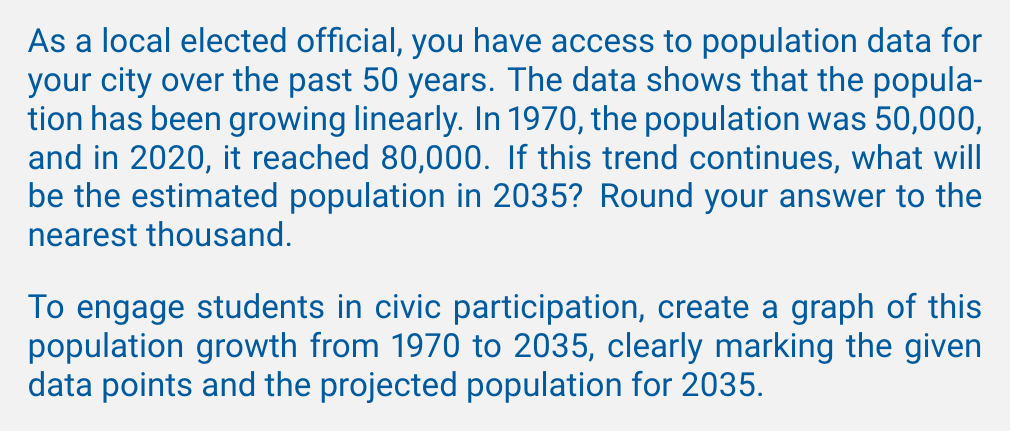Help me with this question. To solve this problem, we need to follow these steps:

1. Calculate the rate of population growth per year:
   Let $y$ represent the population and $x$ represent the years since 1970.
   We can use the point-slope form of a linear equation: $y - y_1 = m(x - x_1)$

   $m = \frac{y_2 - y_1}{x_2 - x_1} = \frac{80,000 - 50,000}{2020 - 1970} = \frac{30,000}{50} = 600$ people per year

2. Write the linear equation for population growth:
   $y - 50,000 = 600(x - 0)$
   $y = 600x + 50,000$

3. Calculate the population in 2035:
   $x = 2035 - 1970 = 65$ years since 1970
   $y = 600(65) + 50,000 = 89,000$

4. To create the graph:
   - X-axis: Years from 1970 to 2035
   - Y-axis: Population from 50,000 to 90,000
   - Plot points: (1970, 50,000), (2020, 80,000), and (2035, 89,000)
   - Draw a straight line through these points

[asy]
import graph;
size(300,200);

real f(real x) {return 600*x + 50000;}

xaxis("Year",Ticks(Label(),2,1970,2035));
yaxis("Population",Ticks(Label(),10000,50000,90000));

draw(graph(f,0,65,operator ..),blue);

dot((0,50000),red);
dot((50,80000),red);
dot((65,89000),red);

label("1970",(0,50000),SW);
label("2020",(50,80000),NW);
label("2035",(65,89000),NE);
[/asy]
Answer: The estimated population in 2035 will be 89,000 people. 